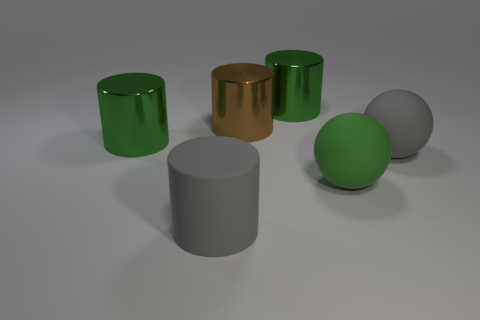There is a large cylinder that is made of the same material as the large gray sphere; what is its color?
Provide a short and direct response. Gray. Is the material of the big gray cylinder the same as the large gray object that is behind the gray cylinder?
Your response must be concise. Yes. How many big green cylinders have the same material as the brown thing?
Give a very brief answer. 2. What shape is the green rubber object that is to the right of the big brown object?
Give a very brief answer. Sphere. Is the material of the gray object that is behind the big gray rubber cylinder the same as the large green cylinder that is on the right side of the large brown object?
Ensure brevity in your answer.  No. Is there a large gray rubber object of the same shape as the big green matte object?
Provide a succinct answer. Yes. How many things are large gray matte things behind the gray cylinder or large green cylinders?
Your response must be concise. 3. Are there more big rubber objects that are to the left of the green rubber ball than gray cylinders that are behind the large brown metallic object?
Make the answer very short. Yes. What number of matte objects are brown things or green cylinders?
Your answer should be very brief. 0. There is a big object that is the same color as the matte cylinder; what material is it?
Your answer should be very brief. Rubber. 